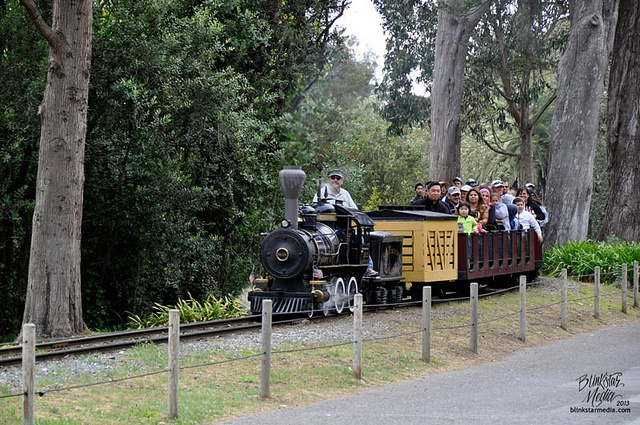Describe the objects in this image and their specific colors. I can see train in black, gray, tan, and darkgray tones, people in black, gray, darkgray, and lavender tones, people in black, lavender, gray, and darkgray tones, people in black, lightgreen, and gray tones, and people in black, gray, and lightpink tones in this image. 